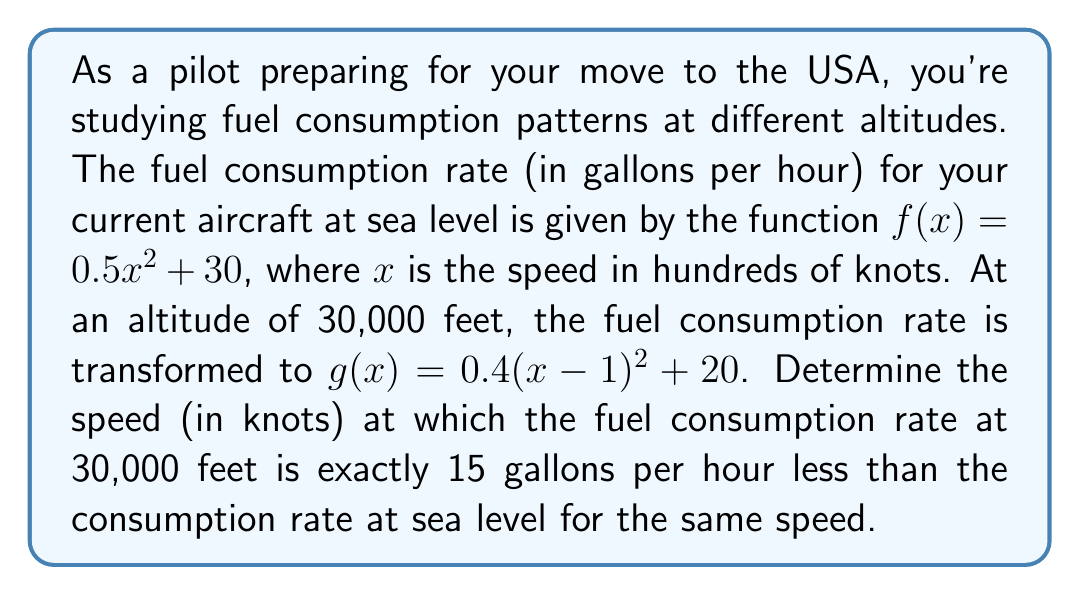Show me your answer to this math problem. Let's approach this step-by-step:

1) We need to find a value of $x$ where $f(x) - g(x) = 15$

2) Let's set up this equation:
   $f(x) - g(x) = 15$

3) Substitute the functions:
   $(0.5x^2 + 30) - (0.4(x-1)^2 + 20) = 15$

4) Expand the squared term in $g(x)$:
   $(0.5x^2 + 30) - (0.4(x^2 - 2x + 1) + 20) = 15$

5) Distribute the 0.4:
   $(0.5x^2 + 30) - (0.4x^2 - 0.8x + 0.4 + 20) = 15$

6) Simplify:
   $0.5x^2 + 30 - 0.4x^2 + 0.8x - 20.4 = 15$

7) Combine like terms:
   $0.1x^2 + 0.8x + 9.6 = 15$

8) Subtract 15 from both sides:
   $0.1x^2 + 0.8x - 5.4 = 0$

9) Multiply everything by 10 to eliminate decimals:
   $x^2 + 8x - 54 = 0$

10) This is a quadratic equation. We can solve it using the quadratic formula:
    $x = \frac{-b \pm \sqrt{b^2 - 4ac}}{2a}$

    Where $a = 1$, $b = 8$, and $c = -54$

11) Plugging in these values:
    $x = \frac{-8 \pm \sqrt{8^2 - 4(1)(-54)}}{2(1)}$
    $= \frac{-8 \pm \sqrt{64 + 216}}{2}$
    $= \frac{-8 \pm \sqrt{280}}{2}$
    $= \frac{-8 \pm 2\sqrt{70}}{2}$

12) This gives us two solutions:
    $x = -4 + \sqrt{70}$ or $x = -4 - \sqrt{70}$

13) Since speed can't be negative, we take the positive solution:
    $x = -4 + \sqrt{70} \approx 4.37$

14) Remember that $x$ was in hundreds of knots, so we multiply by 100:
    Speed $\approx 437$ knots
Answer: The speed at which the fuel consumption rate at 30,000 feet is exactly 15 gallons per hour less than at sea level is approximately 437 knots. 